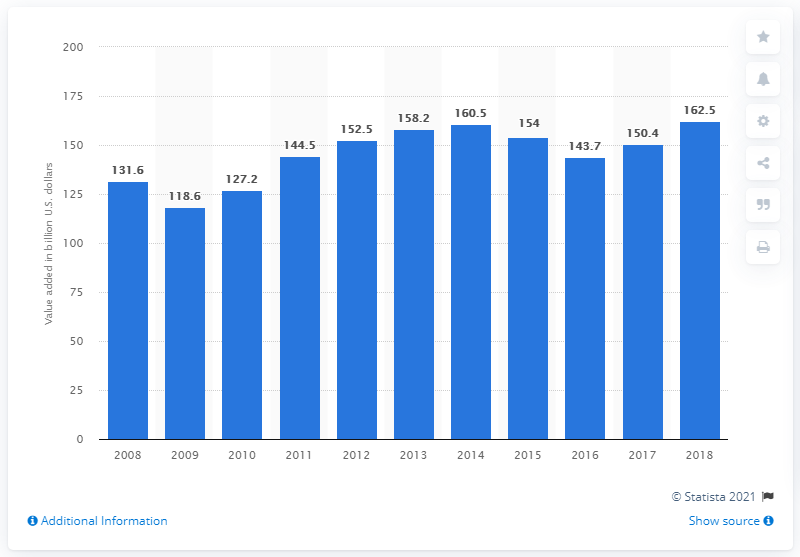List a handful of essential elements in this visual. The machinery manufacturing industry contributed significantly to the economic growth of the United States in 2018, with a contribution of 162.5%. 